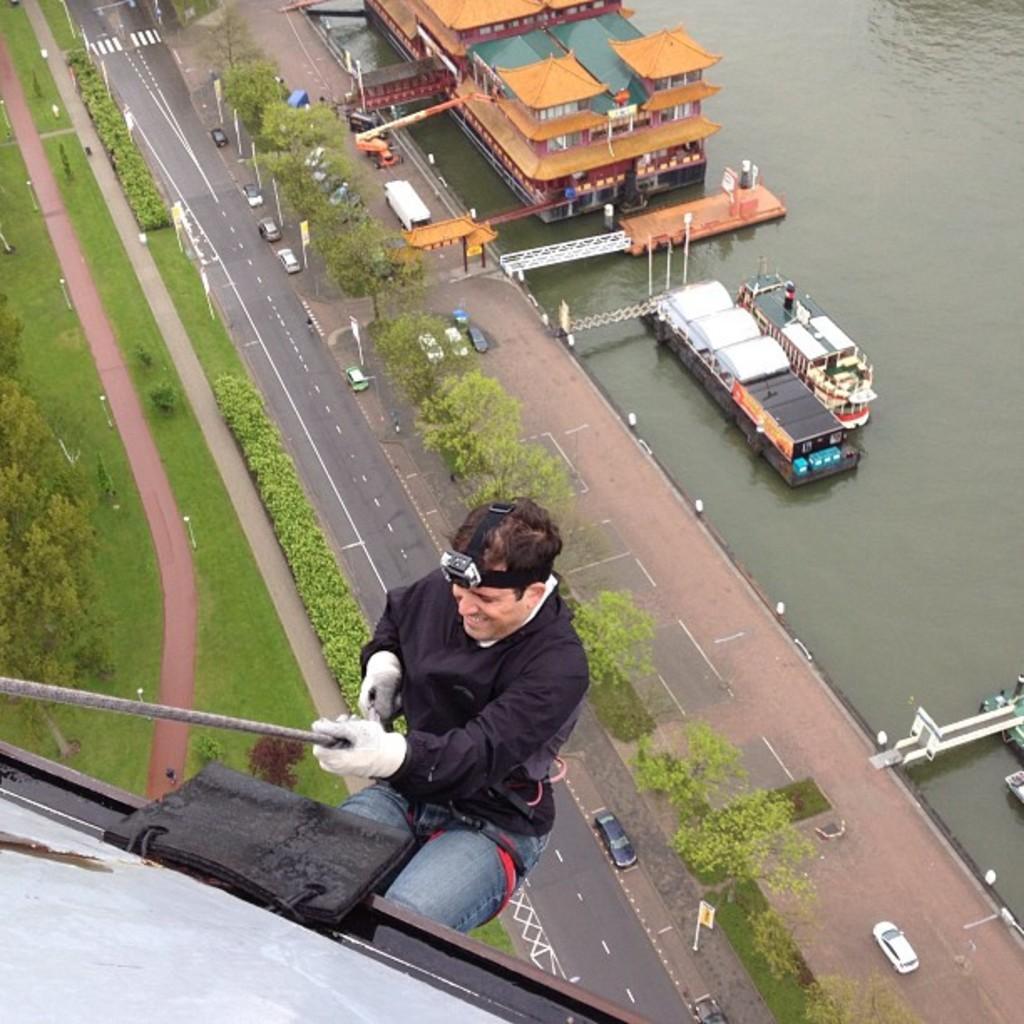Can you describe this image briefly? This image is taken outdoors. At the bottom of the image a man is climbing a building with the help of a rope. On the right side of the image there is a river with water. There are a few boats on the river. In the middle of the image there is a road. Many vehicles are moving on the road and there a few poles and there are many trees and plants. There is a ground with grass on it. 